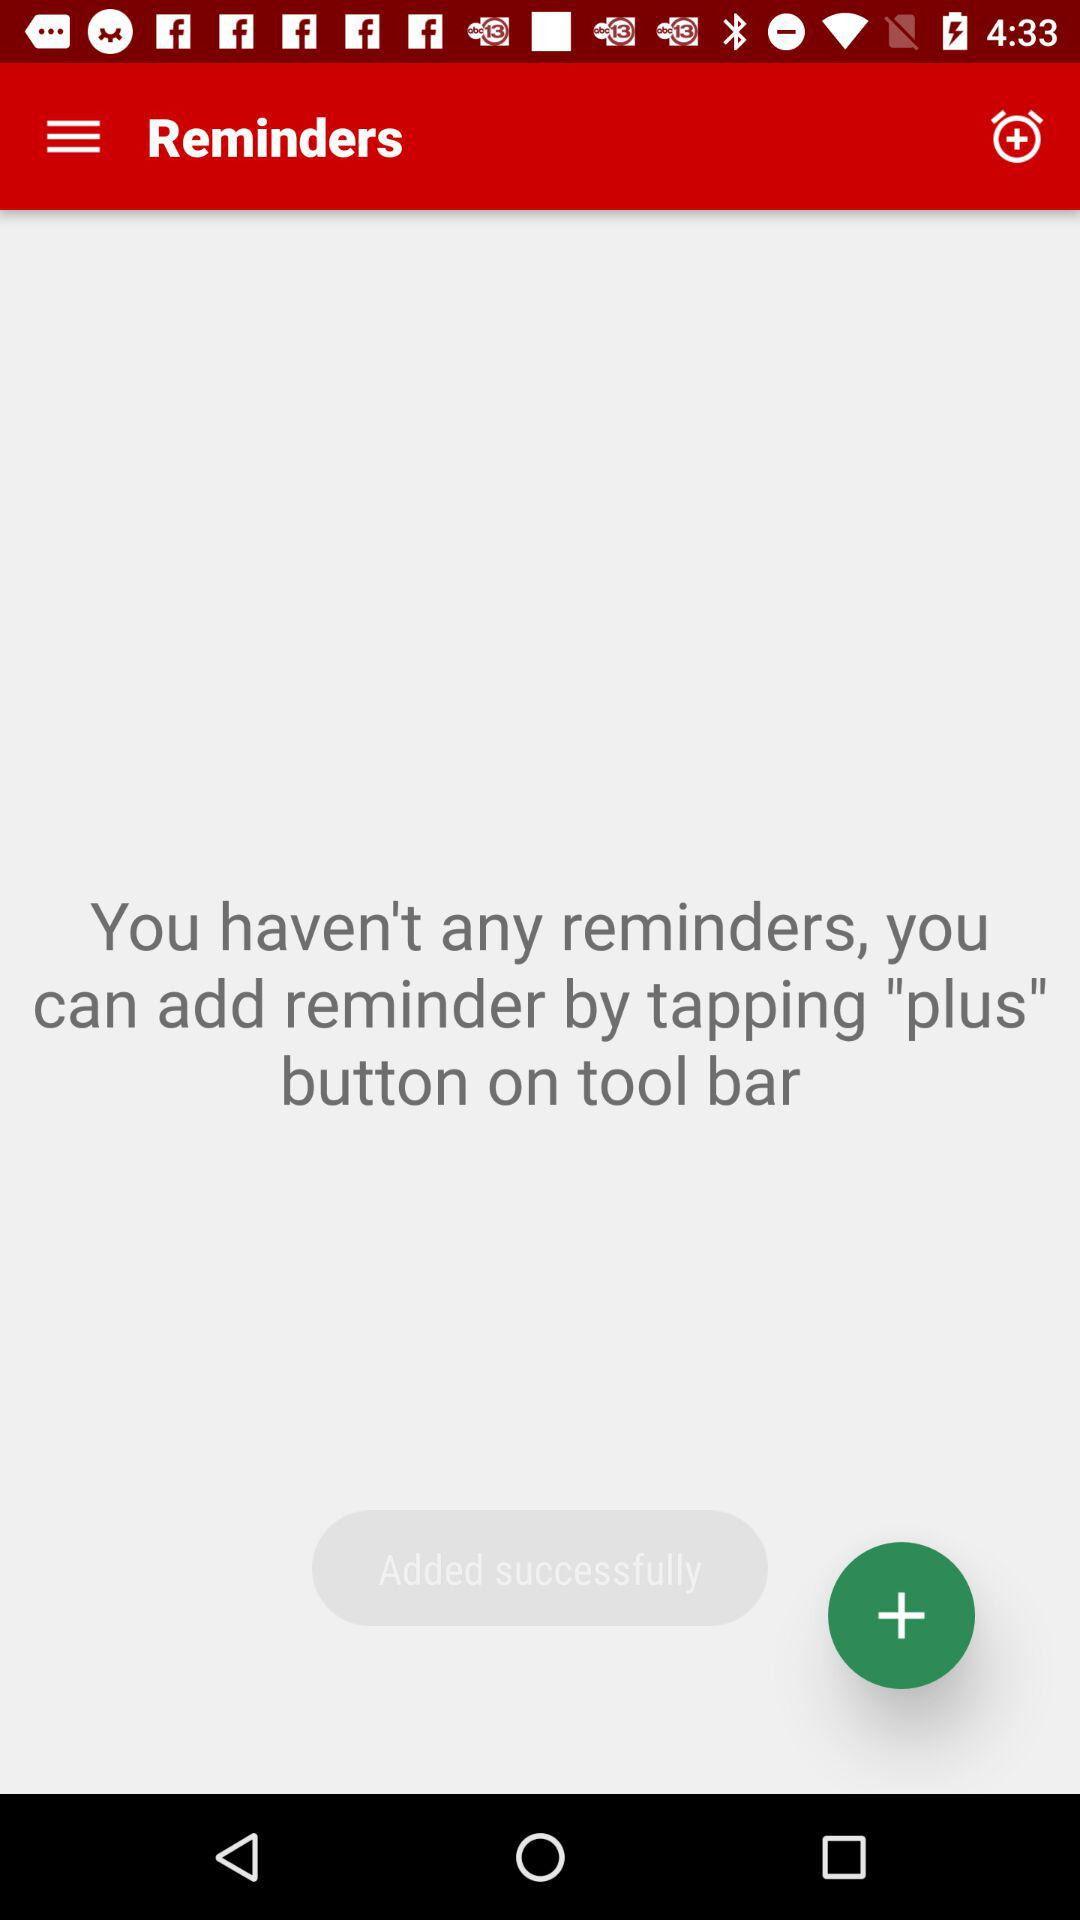Which button do we need to tap to add reminders? You can add a reminder by tapping the "plus" button. 